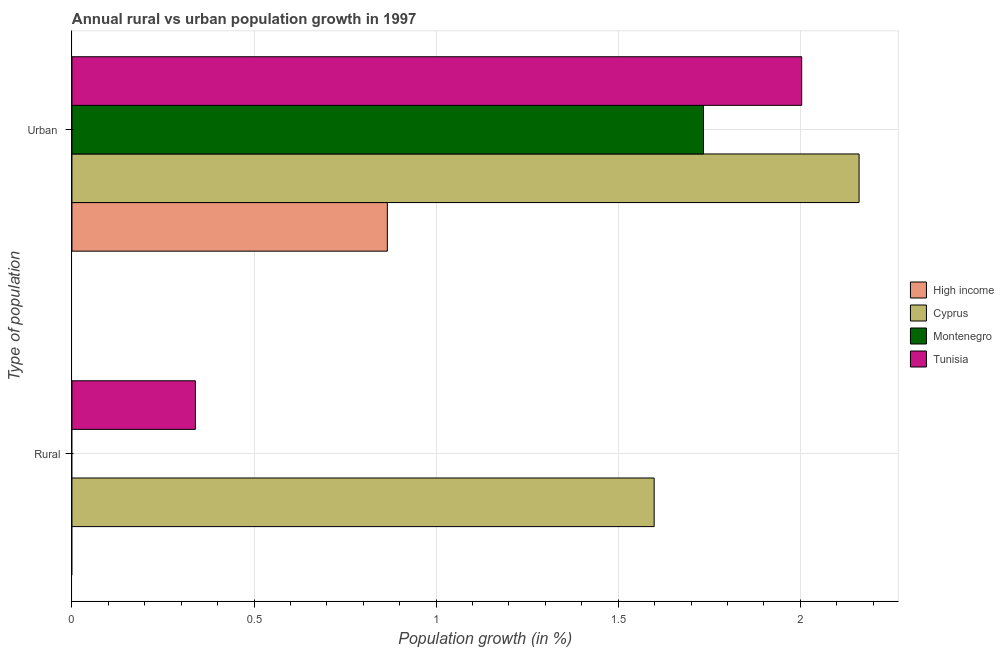How many different coloured bars are there?
Offer a very short reply. 4. Are the number of bars per tick equal to the number of legend labels?
Keep it short and to the point. No. Are the number of bars on each tick of the Y-axis equal?
Your answer should be very brief. No. How many bars are there on the 1st tick from the bottom?
Offer a very short reply. 2. What is the label of the 1st group of bars from the top?
Make the answer very short. Urban . What is the rural population growth in Cyprus?
Give a very brief answer. 1.6. Across all countries, what is the maximum rural population growth?
Provide a succinct answer. 1.6. In which country was the urban population growth maximum?
Keep it short and to the point. Cyprus. What is the total urban population growth in the graph?
Provide a succinct answer. 6.77. What is the difference between the urban population growth in High income and that in Cyprus?
Your response must be concise. -1.3. What is the difference between the urban population growth in Tunisia and the rural population growth in High income?
Offer a very short reply. 2. What is the average rural population growth per country?
Your response must be concise. 0.48. What is the difference between the urban population growth and rural population growth in Tunisia?
Give a very brief answer. 1.66. In how many countries, is the urban population growth greater than 1.8 %?
Your answer should be very brief. 2. What is the ratio of the urban population growth in Cyprus to that in High income?
Make the answer very short. 2.5. Is the urban population growth in Tunisia less than that in Cyprus?
Provide a succinct answer. Yes. In how many countries, is the urban population growth greater than the average urban population growth taken over all countries?
Offer a terse response. 3. How many bars are there?
Provide a succinct answer. 6. Does the graph contain any zero values?
Make the answer very short. Yes. What is the title of the graph?
Offer a terse response. Annual rural vs urban population growth in 1997. What is the label or title of the X-axis?
Your response must be concise. Population growth (in %). What is the label or title of the Y-axis?
Your answer should be very brief. Type of population. What is the Population growth (in %) of High income in Rural?
Ensure brevity in your answer.  0. What is the Population growth (in %) of Cyprus in Rural?
Give a very brief answer. 1.6. What is the Population growth (in %) of Tunisia in Rural?
Offer a very short reply. 0.34. What is the Population growth (in %) of High income in Urban ?
Make the answer very short. 0.87. What is the Population growth (in %) in Cyprus in Urban ?
Give a very brief answer. 2.16. What is the Population growth (in %) of Montenegro in Urban ?
Your answer should be compact. 1.73. What is the Population growth (in %) of Tunisia in Urban ?
Make the answer very short. 2. Across all Type of population, what is the maximum Population growth (in %) of High income?
Your answer should be compact. 0.87. Across all Type of population, what is the maximum Population growth (in %) of Cyprus?
Keep it short and to the point. 2.16. Across all Type of population, what is the maximum Population growth (in %) of Montenegro?
Offer a terse response. 1.73. Across all Type of population, what is the maximum Population growth (in %) in Tunisia?
Ensure brevity in your answer.  2. Across all Type of population, what is the minimum Population growth (in %) in High income?
Ensure brevity in your answer.  0. Across all Type of population, what is the minimum Population growth (in %) of Cyprus?
Provide a short and direct response. 1.6. Across all Type of population, what is the minimum Population growth (in %) in Montenegro?
Provide a succinct answer. 0. Across all Type of population, what is the minimum Population growth (in %) of Tunisia?
Provide a short and direct response. 0.34. What is the total Population growth (in %) of High income in the graph?
Provide a short and direct response. 0.87. What is the total Population growth (in %) in Cyprus in the graph?
Your response must be concise. 3.76. What is the total Population growth (in %) in Montenegro in the graph?
Provide a short and direct response. 1.73. What is the total Population growth (in %) of Tunisia in the graph?
Keep it short and to the point. 2.34. What is the difference between the Population growth (in %) in Cyprus in Rural and that in Urban ?
Your response must be concise. -0.56. What is the difference between the Population growth (in %) of Tunisia in Rural and that in Urban ?
Make the answer very short. -1.67. What is the difference between the Population growth (in %) of Cyprus in Rural and the Population growth (in %) of Montenegro in Urban ?
Offer a very short reply. -0.14. What is the difference between the Population growth (in %) of Cyprus in Rural and the Population growth (in %) of Tunisia in Urban ?
Your response must be concise. -0.41. What is the average Population growth (in %) in High income per Type of population?
Offer a very short reply. 0.43. What is the average Population growth (in %) in Cyprus per Type of population?
Your response must be concise. 1.88. What is the average Population growth (in %) in Montenegro per Type of population?
Your response must be concise. 0.87. What is the average Population growth (in %) of Tunisia per Type of population?
Make the answer very short. 1.17. What is the difference between the Population growth (in %) of Cyprus and Population growth (in %) of Tunisia in Rural?
Your answer should be compact. 1.26. What is the difference between the Population growth (in %) of High income and Population growth (in %) of Cyprus in Urban ?
Ensure brevity in your answer.  -1.3. What is the difference between the Population growth (in %) of High income and Population growth (in %) of Montenegro in Urban ?
Give a very brief answer. -0.87. What is the difference between the Population growth (in %) of High income and Population growth (in %) of Tunisia in Urban ?
Your response must be concise. -1.14. What is the difference between the Population growth (in %) of Cyprus and Population growth (in %) of Montenegro in Urban ?
Make the answer very short. 0.43. What is the difference between the Population growth (in %) in Cyprus and Population growth (in %) in Tunisia in Urban ?
Your answer should be very brief. 0.16. What is the difference between the Population growth (in %) of Montenegro and Population growth (in %) of Tunisia in Urban ?
Offer a very short reply. -0.27. What is the ratio of the Population growth (in %) of Cyprus in Rural to that in Urban ?
Your answer should be compact. 0.74. What is the ratio of the Population growth (in %) of Tunisia in Rural to that in Urban ?
Provide a succinct answer. 0.17. What is the difference between the highest and the second highest Population growth (in %) in Cyprus?
Make the answer very short. 0.56. What is the difference between the highest and the second highest Population growth (in %) of Tunisia?
Your answer should be very brief. 1.67. What is the difference between the highest and the lowest Population growth (in %) in High income?
Your answer should be compact. 0.87. What is the difference between the highest and the lowest Population growth (in %) of Cyprus?
Your answer should be compact. 0.56. What is the difference between the highest and the lowest Population growth (in %) in Montenegro?
Give a very brief answer. 1.73. What is the difference between the highest and the lowest Population growth (in %) in Tunisia?
Keep it short and to the point. 1.67. 